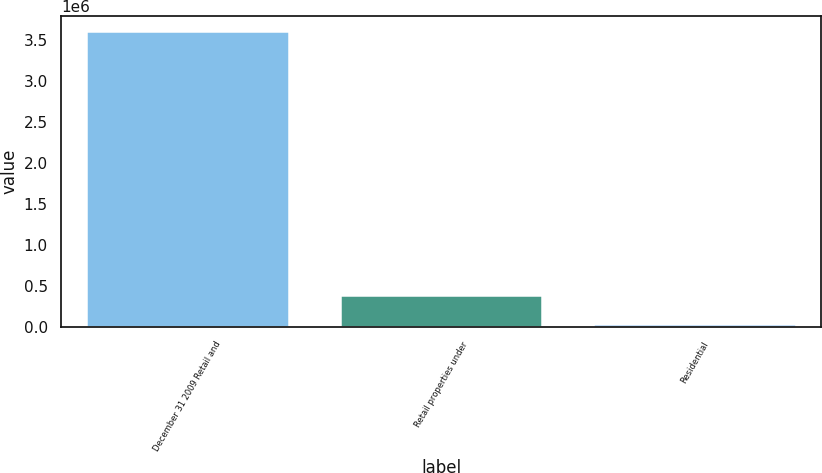Convert chart. <chart><loc_0><loc_0><loc_500><loc_500><bar_chart><fcel>December 31 2009 Retail and<fcel>Retail properties under<fcel>Residential<nl><fcel>3.61551e+06<fcel>386668<fcel>27907<nl></chart> 